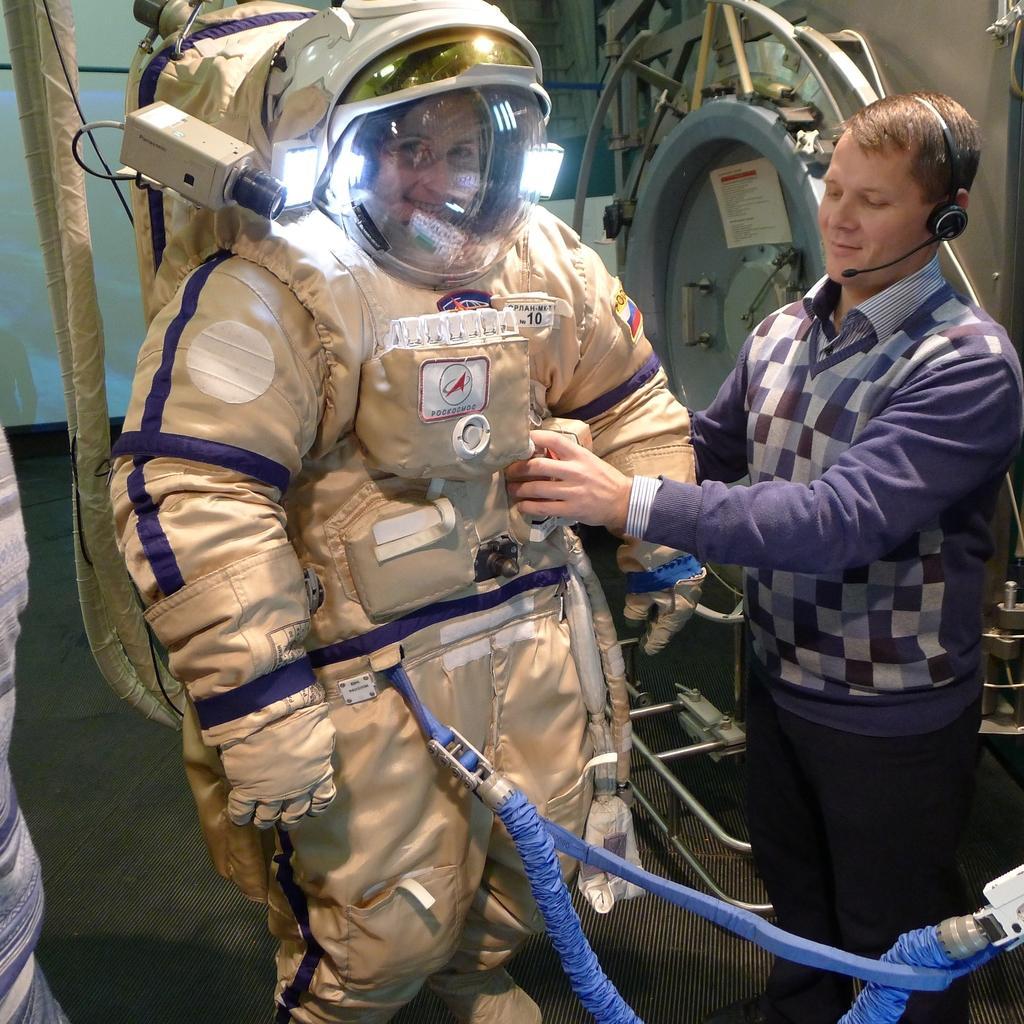Could you give a brief overview of what you see in this image? In this picture there is an astronaut in the center of the image and there is another man who is standing on the right side of the image. 